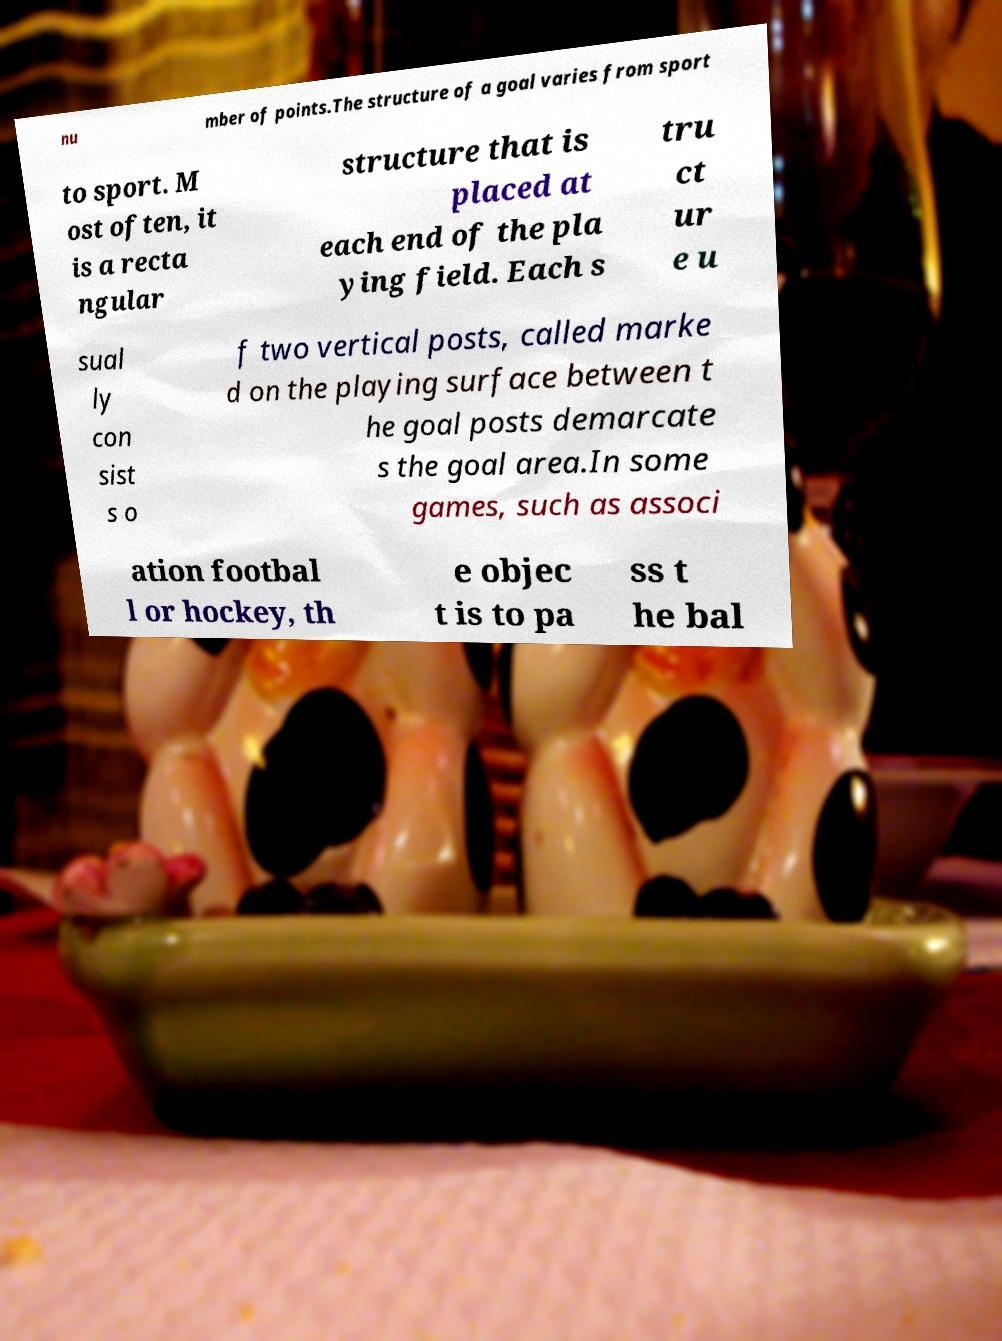Please identify and transcribe the text found in this image. nu mber of points.The structure of a goal varies from sport to sport. M ost often, it is a recta ngular structure that is placed at each end of the pla ying field. Each s tru ct ur e u sual ly con sist s o f two vertical posts, called marke d on the playing surface between t he goal posts demarcate s the goal area.In some games, such as associ ation footbal l or hockey, th e objec t is to pa ss t he bal 